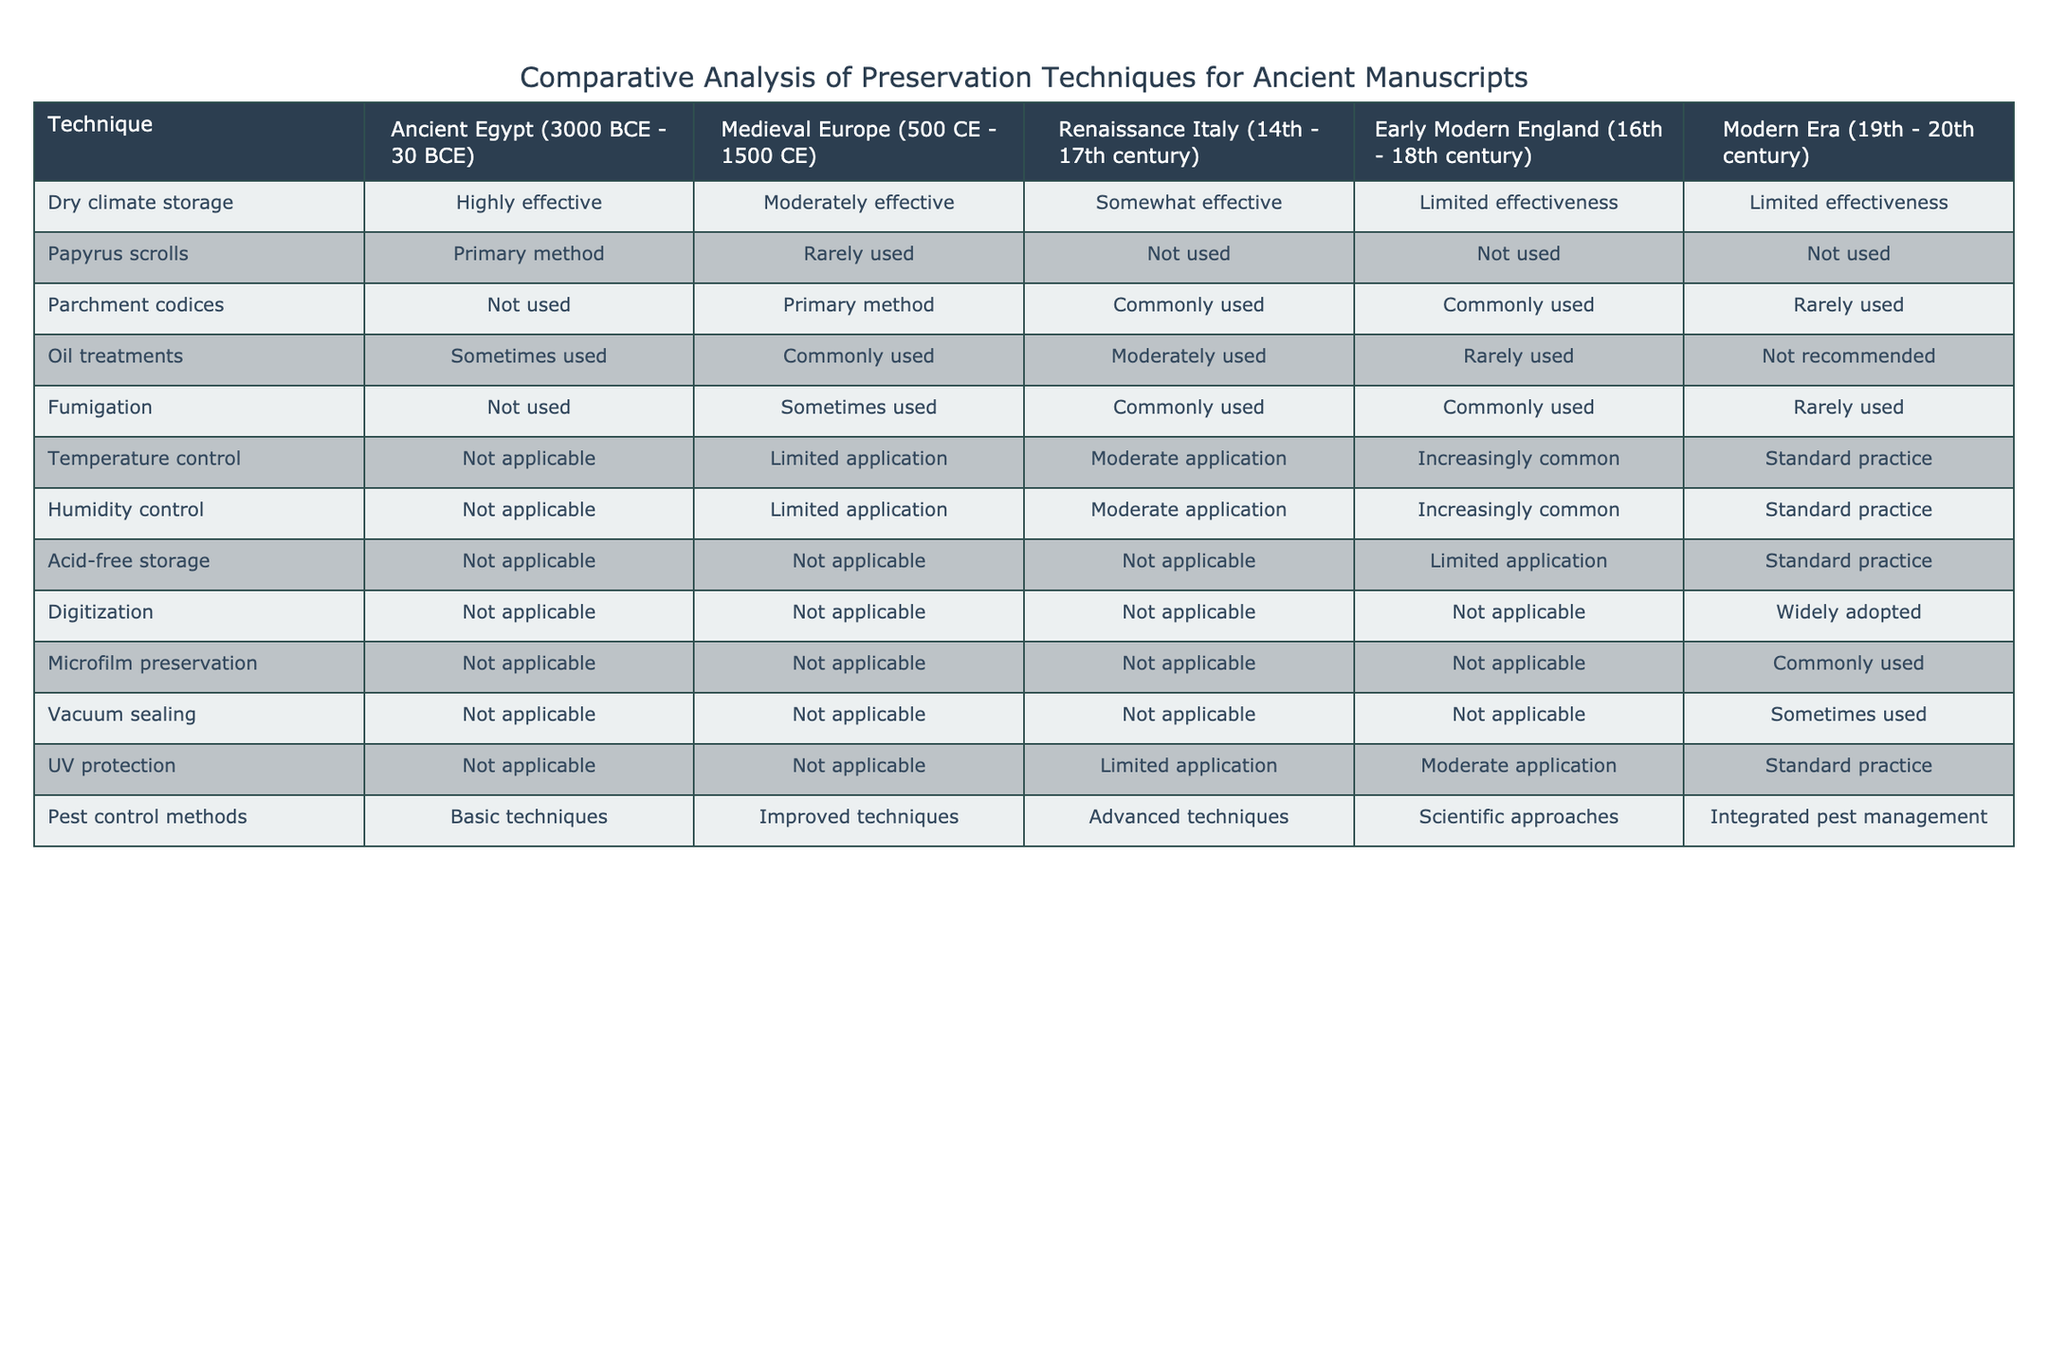What preservation technique was primarily used in Ancient Egypt? According to the table, the primary method of preservation in Ancient Egypt was the use of papyrus scrolls.
Answer: Papyrus scrolls How effective were humidity control methods in Renaissance Italy? The table indicates that humidity control methods had a moderate application in Renaissance Italy, which suggests they were used but not extensively.
Answer: Moderate application Was digitization a common preservation technique in Medieval Europe? The table shows that digitization was not applicable during the Medieval Europe period, indicating it wasn't a common technique.
Answer: No Which preservation technique saw a transition from commonly used in the Renaissance to rarely used in the Modern Era? By examining the table, we can observe that parchment codices were commonly used in the Renaissance but were rarely used in the Modern Era.
Answer: Parchment codices Did early modern England utilize oil treatments effectively? From the data, it's clear that oil treatments were rarely used in early modern England, suggesting low effectiveness during this time.
Answer: No What preservation techniques experienced increasing application from the Early Modern period to the Modern Era? The table highlights that temperature control, humidity control, and acid-free storage saw increasing applications from the Early Modern period to the Modern Era.
Answer: Temperature control, humidity control, acid-free storage Which period did not use fumigation as a preservation technique? The table indicates that fumigation was not used in Ancient Egypt, whereas it was sometimes used in Medieval Europe and became more common in later periods.
Answer: Ancient Egypt How do pest control methods evolve from Ancient Egypt to the Modern Era? The table shows that pest control methods began with basic techniques in Ancient Egypt, improved over Medieval Europe, advanced in Renaissance Italy, and evolved into integrated pest management in the Modern Era.
Answer: Evolved from basic to integrated pest management Which preservation technique is widely adopted in the Modern Era? According to the table, digitization is noted as widely adopted in the Modern Era for preserving manuscripts.
Answer: Digitization How many preservation techniques were limited in their application during Early Modern England? By reviewing the table, limited application techniques in Early Modern England include temperature control, humidity control, and acid-free storage—totalling three techniques.
Answer: Three techniques 